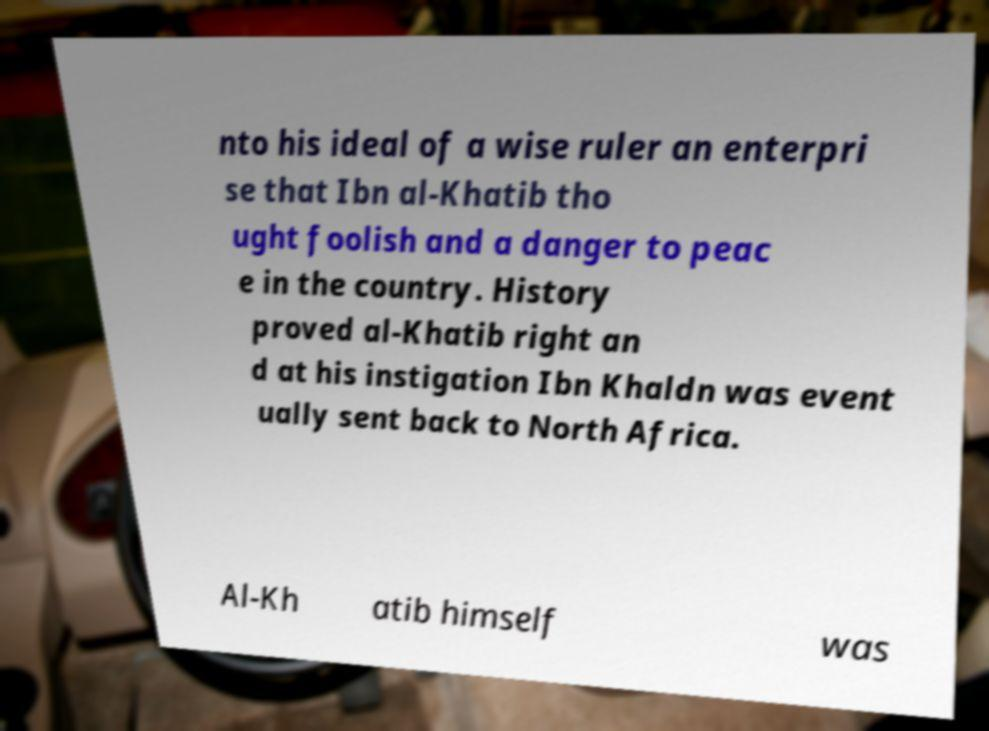I need the written content from this picture converted into text. Can you do that? nto his ideal of a wise ruler an enterpri se that Ibn al-Khatib tho ught foolish and a danger to peac e in the country. History proved al-Khatib right an d at his instigation Ibn Khaldn was event ually sent back to North Africa. Al-Kh atib himself was 